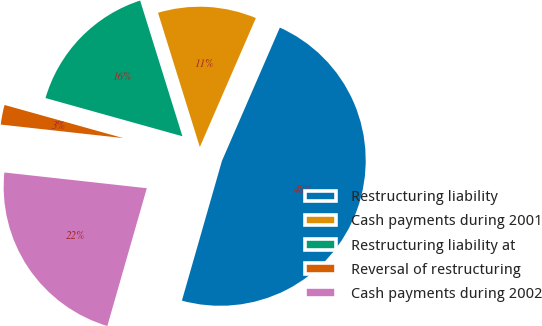<chart> <loc_0><loc_0><loc_500><loc_500><pie_chart><fcel>Restructuring liability<fcel>Cash payments during 2001<fcel>Restructuring liability at<fcel>Reversal of restructuring<fcel>Cash payments during 2002<nl><fcel>47.92%<fcel>11.33%<fcel>15.86%<fcel>2.58%<fcel>22.31%<nl></chart> 